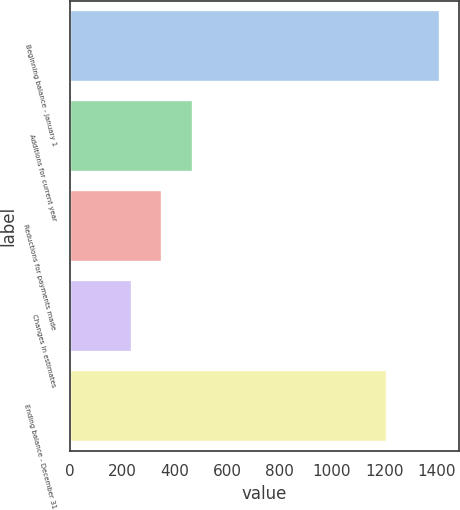Convert chart to OTSL. <chart><loc_0><loc_0><loc_500><loc_500><bar_chart><fcel>Beginning balance - January 1<fcel>Additions for current year<fcel>Reductions for payments made<fcel>Changes in estimates<fcel>Ending balance - December 31<nl><fcel>1414<fcel>471.6<fcel>353.8<fcel>236<fcel>1211<nl></chart> 